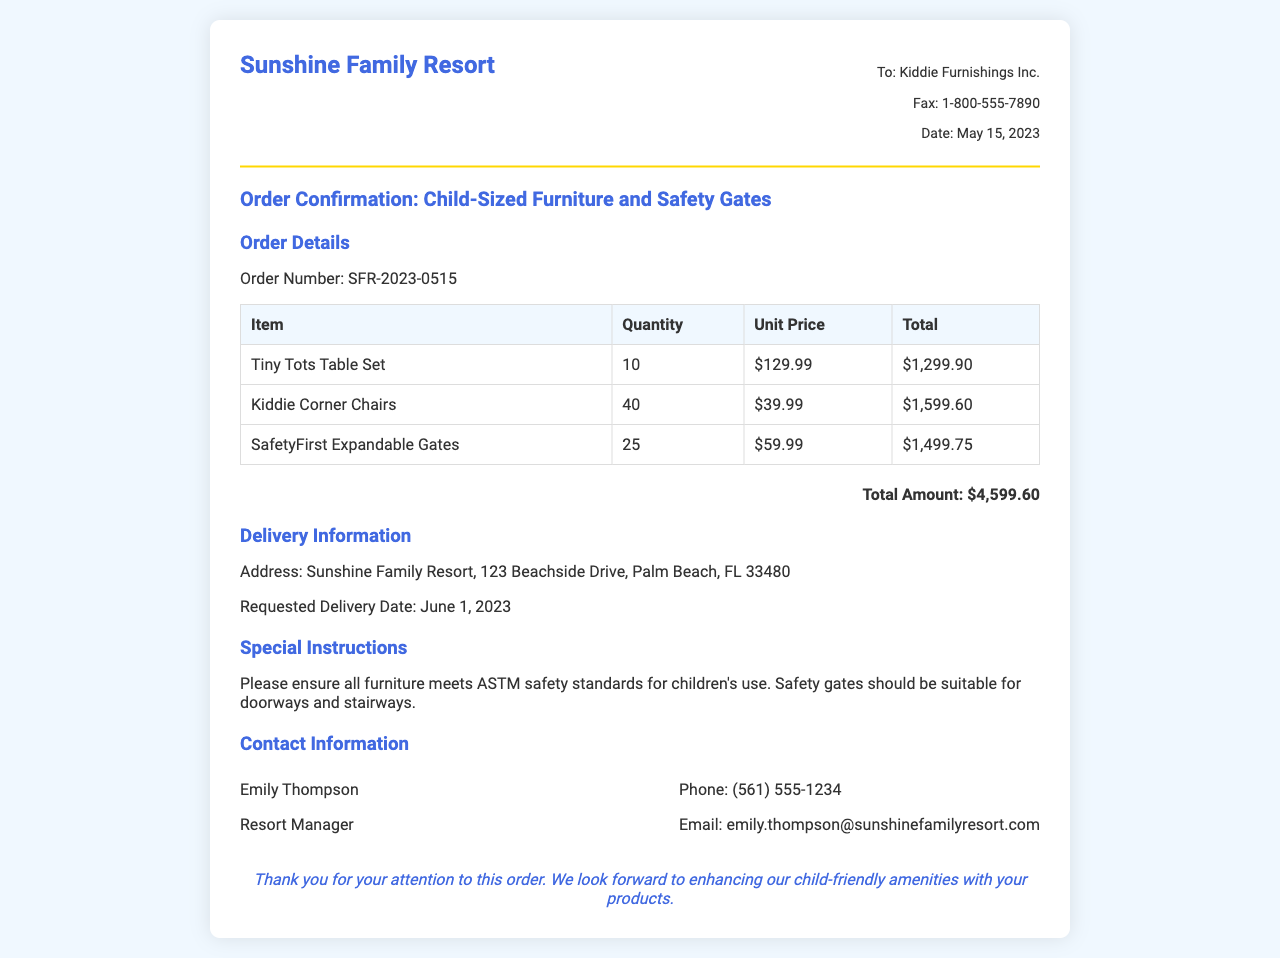what is the order number? The order number uniquely identifies the order in the document and is specified as SFR-2023-0515.
Answer: SFR-2023-0515 who is the contact person? The contact person listed for this order is Emily Thompson, who is the resort manager.
Answer: Emily Thompson what is the total amount for the order? The total amount is calculated by summing the total costs of all items listed in the order, which is $4,599.60.
Answer: $4,599.60 how many Kiddie Corner Chairs were ordered? The quantity of Kiddie Corner Chairs specified in the order details indicates 40 units were ordered.
Answer: 40 what is the requested delivery date? The requested delivery date for the order is mentioned as June 1, 2023.
Answer: June 1, 2023 what safety standards should the furniture meet? The document specifies that all furniture should comply with ASTM safety standards for children's use.
Answer: ASTM safety standards how many SafetyFirst Expandable Gates were ordered? The number of SafetyFirst Expandable Gates ordered is detailed in the information table as 25.
Answer: 25 where is the delivery address? The delivery address for this order is clearly stated as Sunshine Family Resort, 123 Beachside Drive, Palm Beach, FL 33480.
Answer: Sunshine Family Resort, 123 Beachside Drive, Palm Beach, FL 33480 what special instructions are mentioned in the document? The special instructions emphasize ensuring all furniture meets ASTM safety standards and that safety gates are suitable for doorways and stairways.
Answer: Meets ASTM safety standards; suitable for doorways and stairways 